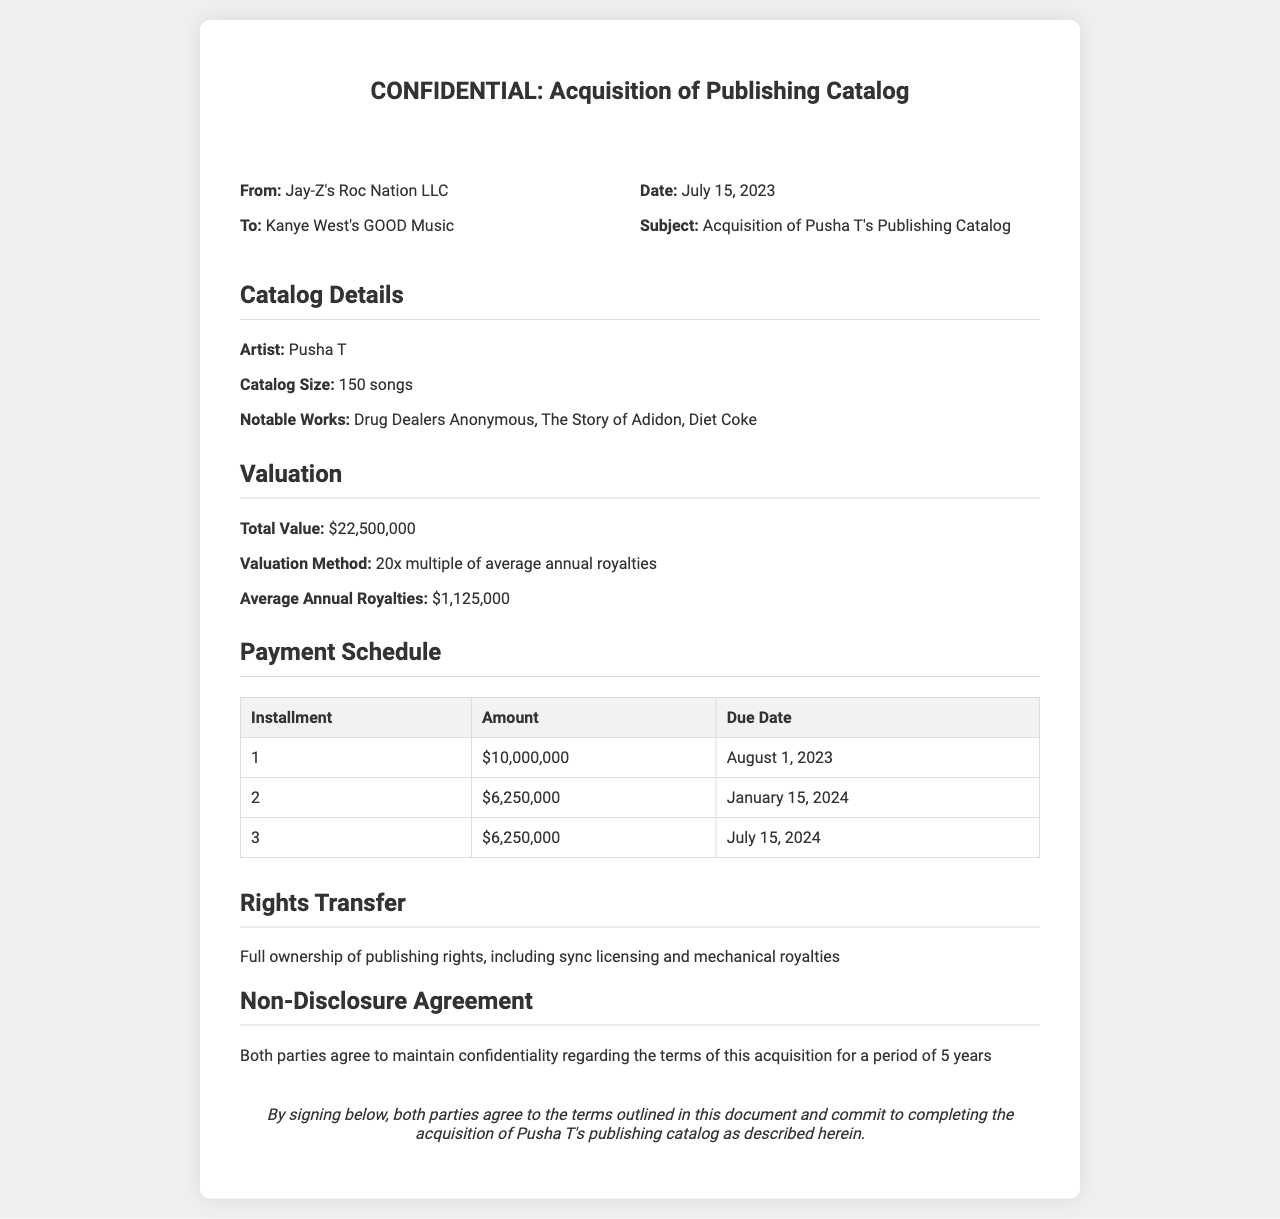what is the total value of the acquisition? The total value of the acquisition is stated in the valuation section of the document as $22,500,000.
Answer: $22,500,000 who is the artist associated with the catalog? The document specifies the artist whose publishing catalog is being acquired as Pusha T.
Answer: Pusha T when is the first payment due? The payment schedule outlines the due date for the first installment as August 1, 2023.
Answer: August 1, 2023 what is the number of songs in the catalog? The catalog details mention that there are 150 songs in total.
Answer: 150 songs how much is the second installment? The payment schedule shows that the second installment amount is $6,250,000.
Answer: $6,250,000 what is the valuation method used? The document states that the valuation method is a 20x multiple of average annual royalties.
Answer: 20x multiple of average annual royalties how long will the non-disclosure agreement last? The non-disclosure agreement specifies a duration of confidentiality for a period of 5 years.
Answer: 5 years what types of rights are transferred in the acquisition? The rights transfer section mentions full ownership of publishing rights, including sync licensing and mechanical royalties.
Answer: Publishing rights, sync licensing, mechanical royalties 